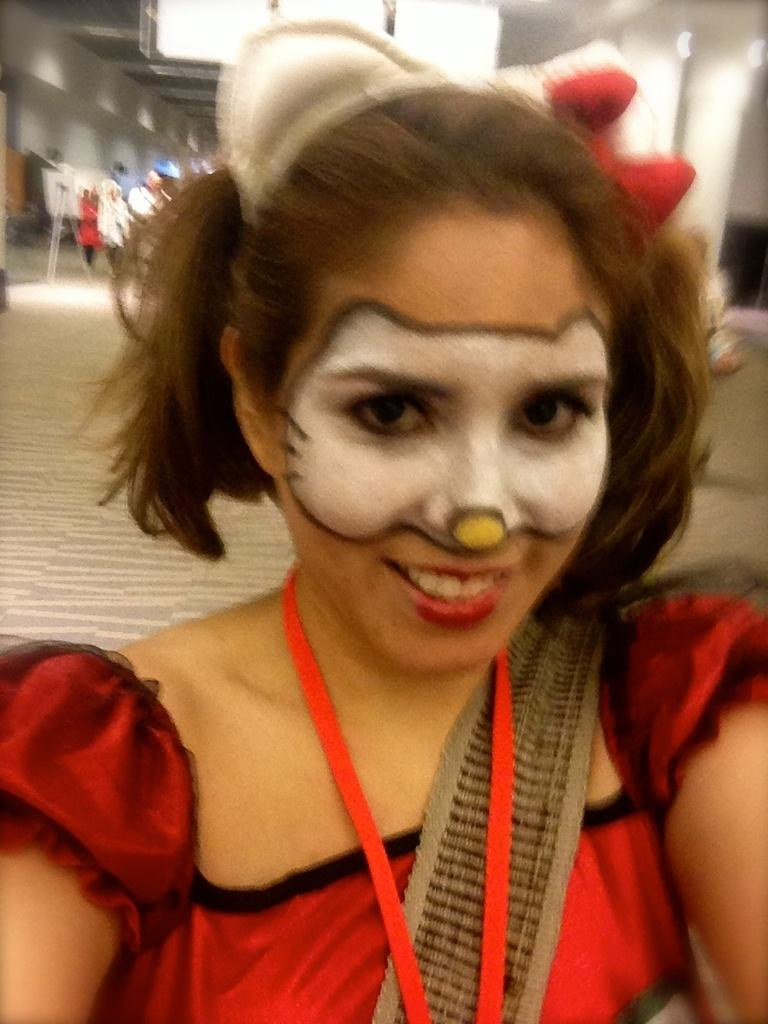Who is the main subject in the image? There is a woman in the image. What is unique about the woman's appearance? The woman has painted her face. What is the woman wearing? The woman is wearing a red dress. Can you describe the people in the background of the image? There are other people standing in the background of the image, and they are standing on the floor. What type of religion is being practiced in the image? There is no indication of any religious practice in the image. How comfortable are the people in the image? The image does not provide any information about the comfort level of the people. 